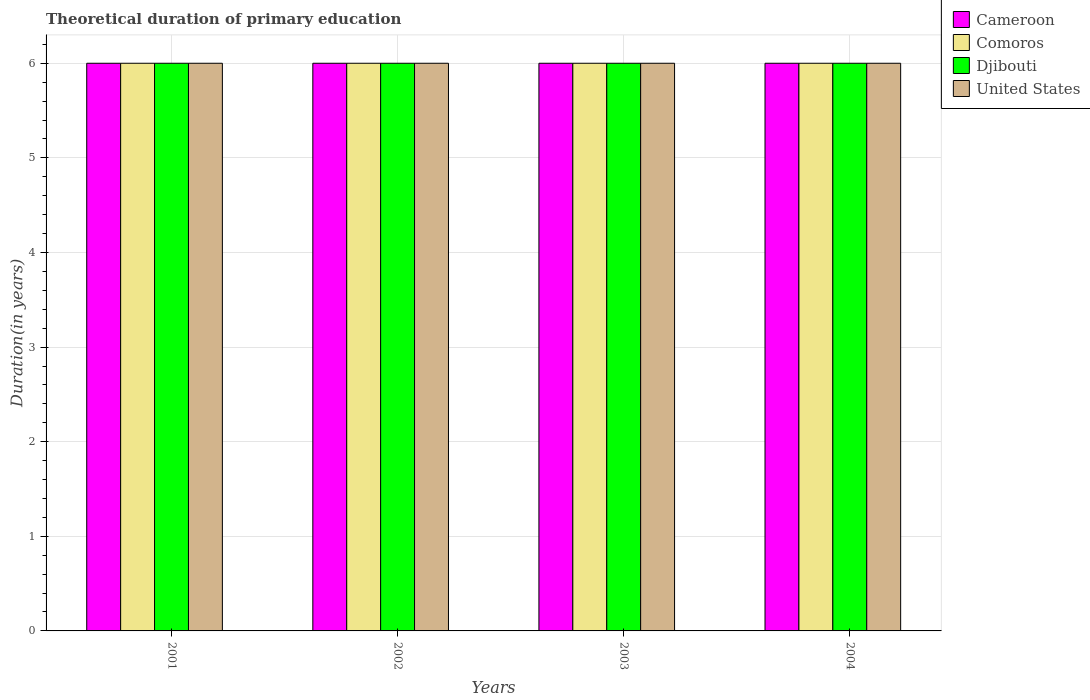How many different coloured bars are there?
Your answer should be very brief. 4. Are the number of bars on each tick of the X-axis equal?
Ensure brevity in your answer.  Yes. What is the label of the 4th group of bars from the left?
Provide a succinct answer. 2004. What is the total theoretical duration of primary education in Comoros in 2002?
Provide a succinct answer. 6. In which year was the total theoretical duration of primary education in Comoros maximum?
Ensure brevity in your answer.  2001. In which year was the total theoretical duration of primary education in United States minimum?
Offer a terse response. 2001. What is the total total theoretical duration of primary education in United States in the graph?
Provide a succinct answer. 24. What is the difference between the total theoretical duration of primary education in Cameroon in 2002 and that in 2003?
Ensure brevity in your answer.  0. What is the average total theoretical duration of primary education in Comoros per year?
Give a very brief answer. 6. In the year 2004, what is the difference between the total theoretical duration of primary education in Djibouti and total theoretical duration of primary education in United States?
Your answer should be compact. 0. In how many years, is the total theoretical duration of primary education in Djibouti greater than 5.4 years?
Your answer should be compact. 4. What is the difference between the highest and the lowest total theoretical duration of primary education in United States?
Ensure brevity in your answer.  0. In how many years, is the total theoretical duration of primary education in Comoros greater than the average total theoretical duration of primary education in Comoros taken over all years?
Provide a short and direct response. 0. Is the sum of the total theoretical duration of primary education in United States in 2001 and 2002 greater than the maximum total theoretical duration of primary education in Cameroon across all years?
Your response must be concise. Yes. Is it the case that in every year, the sum of the total theoretical duration of primary education in United States and total theoretical duration of primary education in Djibouti is greater than the sum of total theoretical duration of primary education in Cameroon and total theoretical duration of primary education in Comoros?
Provide a short and direct response. No. What does the 4th bar from the left in 2003 represents?
Offer a very short reply. United States. What does the 2nd bar from the right in 2001 represents?
Your response must be concise. Djibouti. Is it the case that in every year, the sum of the total theoretical duration of primary education in Comoros and total theoretical duration of primary education in Cameroon is greater than the total theoretical duration of primary education in Djibouti?
Your answer should be compact. Yes. What is the difference between two consecutive major ticks on the Y-axis?
Your response must be concise. 1. Does the graph contain any zero values?
Your answer should be compact. No. What is the title of the graph?
Offer a terse response. Theoretical duration of primary education. Does "Paraguay" appear as one of the legend labels in the graph?
Offer a terse response. No. What is the label or title of the X-axis?
Keep it short and to the point. Years. What is the label or title of the Y-axis?
Provide a succinct answer. Duration(in years). What is the Duration(in years) in Comoros in 2001?
Give a very brief answer. 6. What is the Duration(in years) in Djibouti in 2001?
Offer a terse response. 6. What is the Duration(in years) of United States in 2001?
Offer a very short reply. 6. What is the Duration(in years) of Cameroon in 2002?
Give a very brief answer. 6. What is the Duration(in years) of Djibouti in 2003?
Provide a succinct answer. 6. What is the Duration(in years) in Cameroon in 2004?
Offer a very short reply. 6. What is the Duration(in years) in Comoros in 2004?
Ensure brevity in your answer.  6. Across all years, what is the maximum Duration(in years) in Cameroon?
Provide a short and direct response. 6. Across all years, what is the maximum Duration(in years) in Djibouti?
Ensure brevity in your answer.  6. Across all years, what is the maximum Duration(in years) in United States?
Offer a terse response. 6. Across all years, what is the minimum Duration(in years) in Cameroon?
Your answer should be very brief. 6. Across all years, what is the minimum Duration(in years) of Comoros?
Your answer should be very brief. 6. Across all years, what is the minimum Duration(in years) of Djibouti?
Your answer should be very brief. 6. Across all years, what is the minimum Duration(in years) of United States?
Provide a succinct answer. 6. What is the total Duration(in years) of Comoros in the graph?
Provide a short and direct response. 24. What is the total Duration(in years) in United States in the graph?
Provide a succinct answer. 24. What is the difference between the Duration(in years) in Cameroon in 2001 and that in 2003?
Your answer should be compact. 0. What is the difference between the Duration(in years) in Djibouti in 2001 and that in 2003?
Offer a very short reply. 0. What is the difference between the Duration(in years) of United States in 2001 and that in 2003?
Make the answer very short. 0. What is the difference between the Duration(in years) in Djibouti in 2001 and that in 2004?
Your response must be concise. 0. What is the difference between the Duration(in years) of United States in 2001 and that in 2004?
Offer a very short reply. 0. What is the difference between the Duration(in years) in Cameroon in 2002 and that in 2003?
Offer a terse response. 0. What is the difference between the Duration(in years) in Comoros in 2002 and that in 2003?
Your response must be concise. 0. What is the difference between the Duration(in years) in Djibouti in 2002 and that in 2003?
Ensure brevity in your answer.  0. What is the difference between the Duration(in years) of United States in 2002 and that in 2003?
Make the answer very short. 0. What is the difference between the Duration(in years) of Djibouti in 2002 and that in 2004?
Offer a very short reply. 0. What is the difference between the Duration(in years) in United States in 2002 and that in 2004?
Ensure brevity in your answer.  0. What is the difference between the Duration(in years) in Djibouti in 2003 and that in 2004?
Ensure brevity in your answer.  0. What is the difference between the Duration(in years) of Cameroon in 2001 and the Duration(in years) of United States in 2002?
Provide a succinct answer. 0. What is the difference between the Duration(in years) of Cameroon in 2001 and the Duration(in years) of Djibouti in 2003?
Ensure brevity in your answer.  0. What is the difference between the Duration(in years) in Comoros in 2001 and the Duration(in years) in Djibouti in 2003?
Offer a very short reply. 0. What is the difference between the Duration(in years) in Comoros in 2001 and the Duration(in years) in United States in 2003?
Provide a succinct answer. 0. What is the difference between the Duration(in years) in Djibouti in 2001 and the Duration(in years) in United States in 2003?
Ensure brevity in your answer.  0. What is the difference between the Duration(in years) of Comoros in 2001 and the Duration(in years) of United States in 2004?
Ensure brevity in your answer.  0. What is the difference between the Duration(in years) of Cameroon in 2002 and the Duration(in years) of United States in 2003?
Provide a succinct answer. 0. What is the difference between the Duration(in years) in Cameroon in 2002 and the Duration(in years) in United States in 2004?
Your answer should be very brief. 0. What is the difference between the Duration(in years) in Comoros in 2002 and the Duration(in years) in Djibouti in 2004?
Ensure brevity in your answer.  0. What is the difference between the Duration(in years) in Djibouti in 2002 and the Duration(in years) in United States in 2004?
Keep it short and to the point. 0. What is the difference between the Duration(in years) in Cameroon in 2003 and the Duration(in years) in Comoros in 2004?
Provide a succinct answer. 0. What is the difference between the Duration(in years) in Cameroon in 2003 and the Duration(in years) in Djibouti in 2004?
Your answer should be very brief. 0. What is the difference between the Duration(in years) of Comoros in 2003 and the Duration(in years) of Djibouti in 2004?
Your answer should be very brief. 0. What is the average Duration(in years) in Cameroon per year?
Ensure brevity in your answer.  6. What is the average Duration(in years) in Comoros per year?
Ensure brevity in your answer.  6. What is the average Duration(in years) in Djibouti per year?
Offer a terse response. 6. What is the average Duration(in years) of United States per year?
Your answer should be compact. 6. In the year 2001, what is the difference between the Duration(in years) in Cameroon and Duration(in years) in Comoros?
Offer a terse response. 0. In the year 2001, what is the difference between the Duration(in years) of Cameroon and Duration(in years) of Djibouti?
Offer a very short reply. 0. In the year 2001, what is the difference between the Duration(in years) in Comoros and Duration(in years) in United States?
Make the answer very short. 0. In the year 2002, what is the difference between the Duration(in years) of Cameroon and Duration(in years) of Comoros?
Your answer should be very brief. 0. In the year 2002, what is the difference between the Duration(in years) in Comoros and Duration(in years) in Djibouti?
Provide a succinct answer. 0. In the year 2003, what is the difference between the Duration(in years) in Cameroon and Duration(in years) in Comoros?
Your answer should be very brief. 0. In the year 2003, what is the difference between the Duration(in years) in Cameroon and Duration(in years) in Djibouti?
Your response must be concise. 0. In the year 2003, what is the difference between the Duration(in years) in Cameroon and Duration(in years) in United States?
Your response must be concise. 0. In the year 2004, what is the difference between the Duration(in years) of Cameroon and Duration(in years) of United States?
Your answer should be compact. 0. In the year 2004, what is the difference between the Duration(in years) of Comoros and Duration(in years) of Djibouti?
Provide a short and direct response. 0. In the year 2004, what is the difference between the Duration(in years) in Comoros and Duration(in years) in United States?
Your response must be concise. 0. What is the ratio of the Duration(in years) in Cameroon in 2001 to that in 2002?
Provide a short and direct response. 1. What is the ratio of the Duration(in years) of Djibouti in 2001 to that in 2002?
Make the answer very short. 1. What is the ratio of the Duration(in years) of Cameroon in 2001 to that in 2003?
Your answer should be compact. 1. What is the ratio of the Duration(in years) in Djibouti in 2001 to that in 2003?
Provide a succinct answer. 1. What is the ratio of the Duration(in years) in Djibouti in 2001 to that in 2004?
Ensure brevity in your answer.  1. What is the ratio of the Duration(in years) in United States in 2001 to that in 2004?
Your answer should be very brief. 1. What is the ratio of the Duration(in years) of Cameroon in 2002 to that in 2003?
Your response must be concise. 1. What is the ratio of the Duration(in years) in Djibouti in 2002 to that in 2003?
Offer a terse response. 1. What is the ratio of the Duration(in years) of Cameroon in 2002 to that in 2004?
Your answer should be very brief. 1. What is the ratio of the Duration(in years) of United States in 2002 to that in 2004?
Your answer should be compact. 1. What is the difference between the highest and the second highest Duration(in years) in Comoros?
Provide a short and direct response. 0. What is the difference between the highest and the second highest Duration(in years) of Djibouti?
Offer a very short reply. 0. What is the difference between the highest and the lowest Duration(in years) in Comoros?
Provide a succinct answer. 0. What is the difference between the highest and the lowest Duration(in years) in Djibouti?
Your response must be concise. 0. 